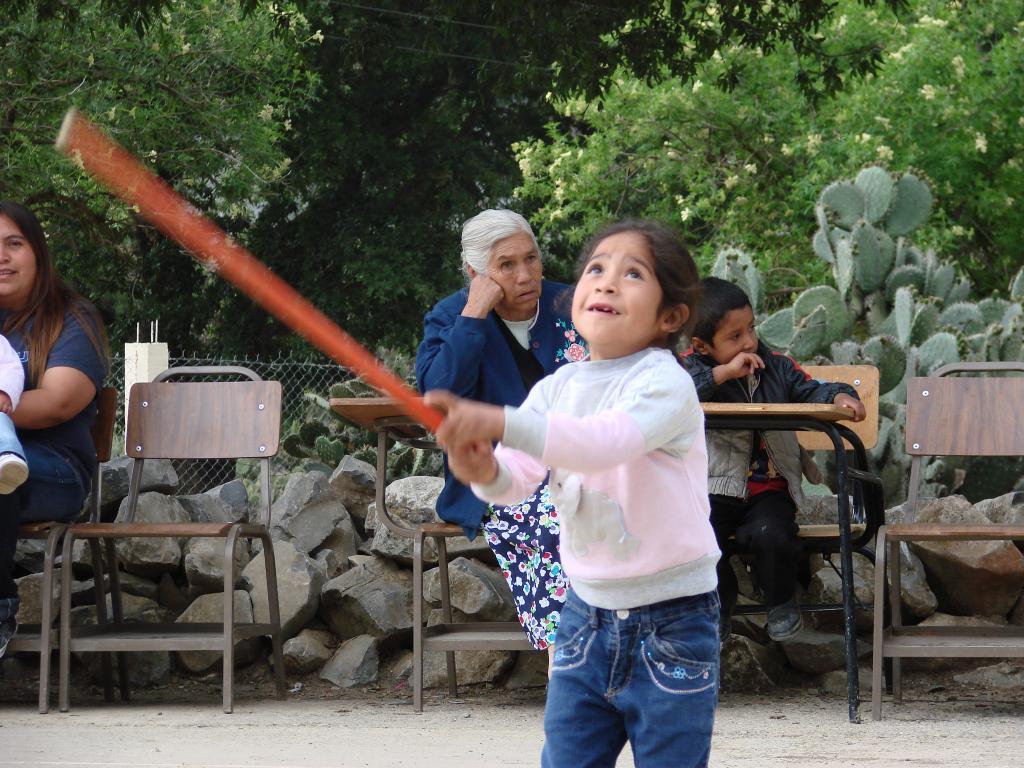Please provide a concise description of this image. In this picture a kid is playing with a stick in her hand and there are people sitting on chairs in the background. There are people sitting on the chairs in the background. 